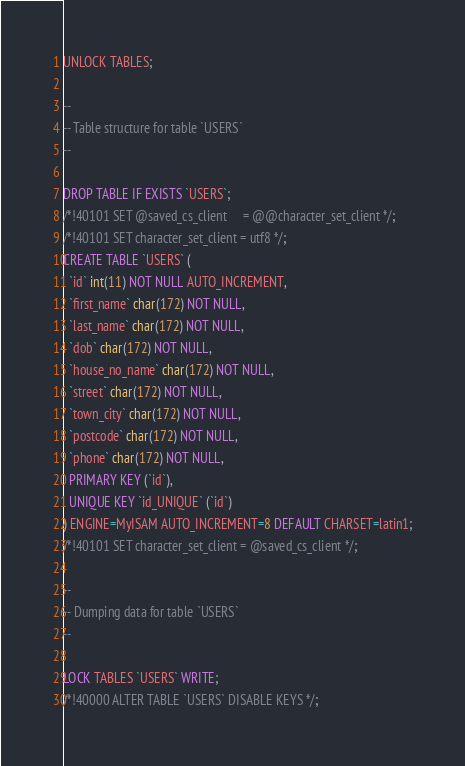<code> <loc_0><loc_0><loc_500><loc_500><_SQL_>UNLOCK TABLES;

--
-- Table structure for table `USERS`
--

DROP TABLE IF EXISTS `USERS`;
/*!40101 SET @saved_cs_client     = @@character_set_client */;
/*!40101 SET character_set_client = utf8 */;
CREATE TABLE `USERS` (
  `id` int(11) NOT NULL AUTO_INCREMENT,
  `first_name` char(172) NOT NULL,
  `last_name` char(172) NOT NULL,
  `dob` char(172) NOT NULL,
  `house_no_name` char(172) NOT NULL,
  `street` char(172) NOT NULL,
  `town_city` char(172) NOT NULL,
  `postcode` char(172) NOT NULL,
  `phone` char(172) NOT NULL,
  PRIMARY KEY (`id`),
  UNIQUE KEY `id_UNIQUE` (`id`)
) ENGINE=MyISAM AUTO_INCREMENT=8 DEFAULT CHARSET=latin1;
/*!40101 SET character_set_client = @saved_cs_client */;

--
-- Dumping data for table `USERS`
--

LOCK TABLES `USERS` WRITE;
/*!40000 ALTER TABLE `USERS` DISABLE KEYS */;</code> 